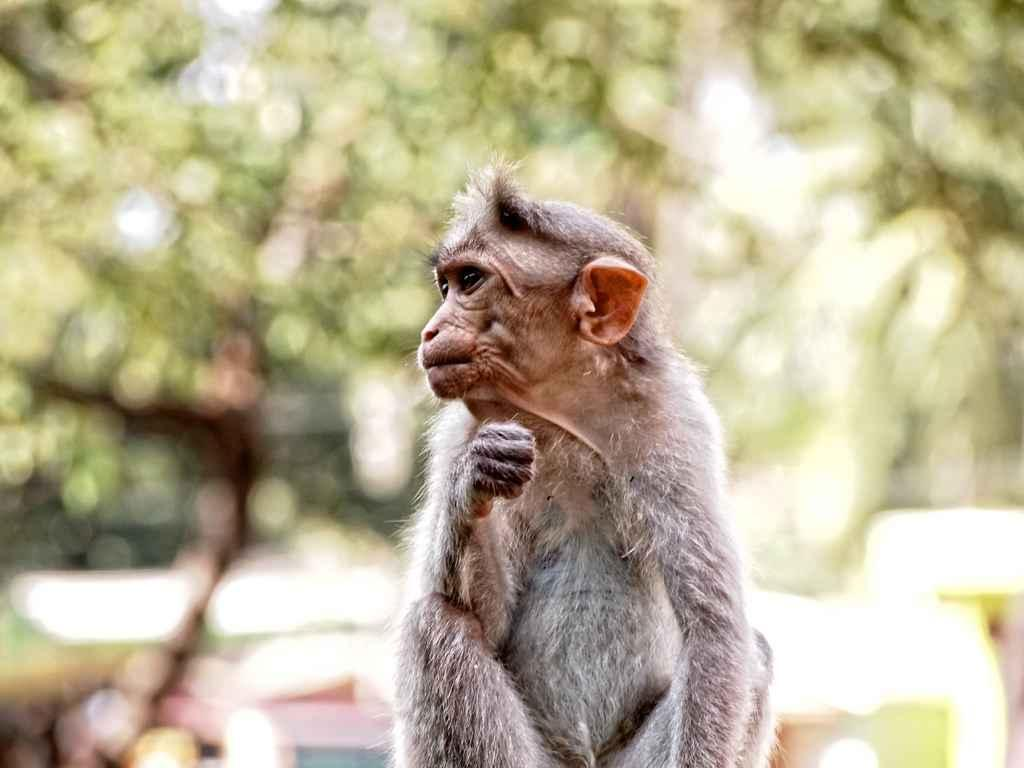What animal is present in the image? There is a monkey in the image. What is the monkey doing in the image? The monkey is sitting. What can be seen in the background of the image? There are trees in the background of the image. What song is the monkey singing in the image? There is no indication in the image that the monkey is singing a song. 